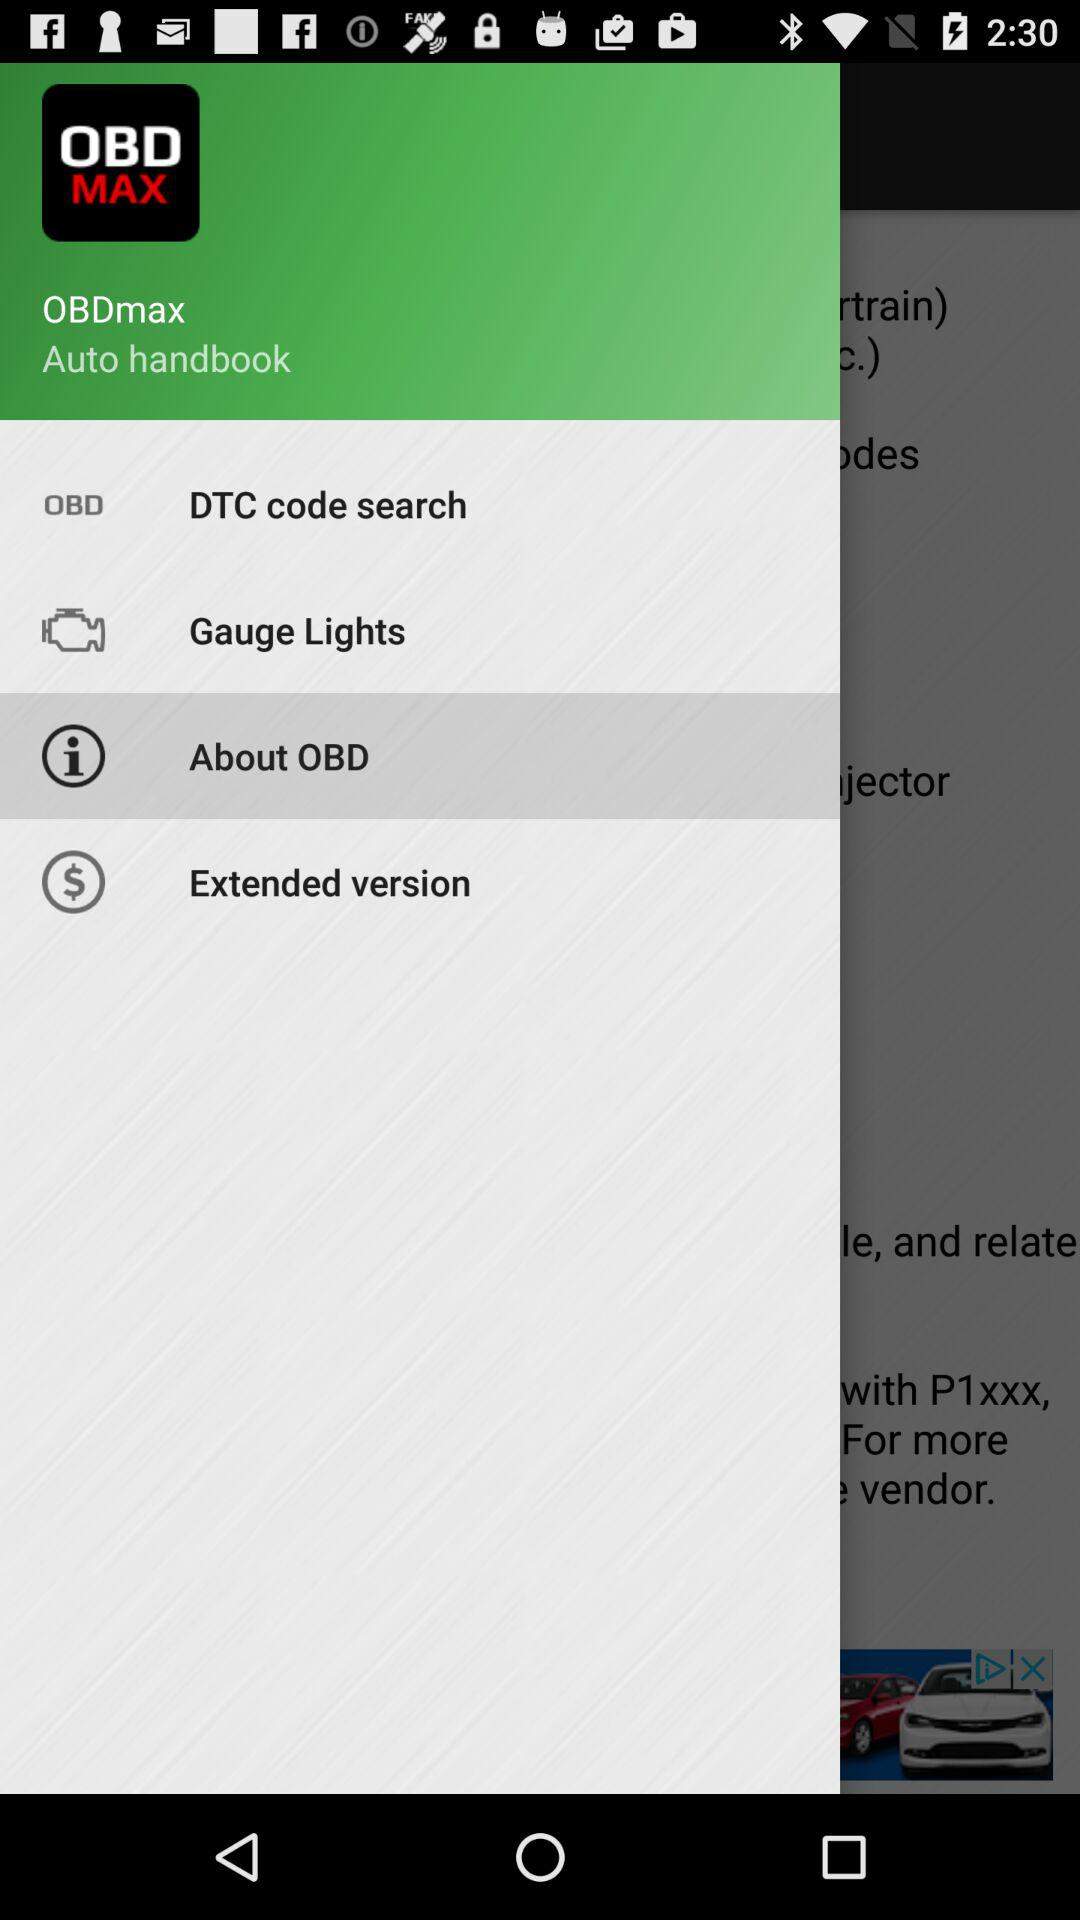What is the app name? The app name is "OBDmax". 